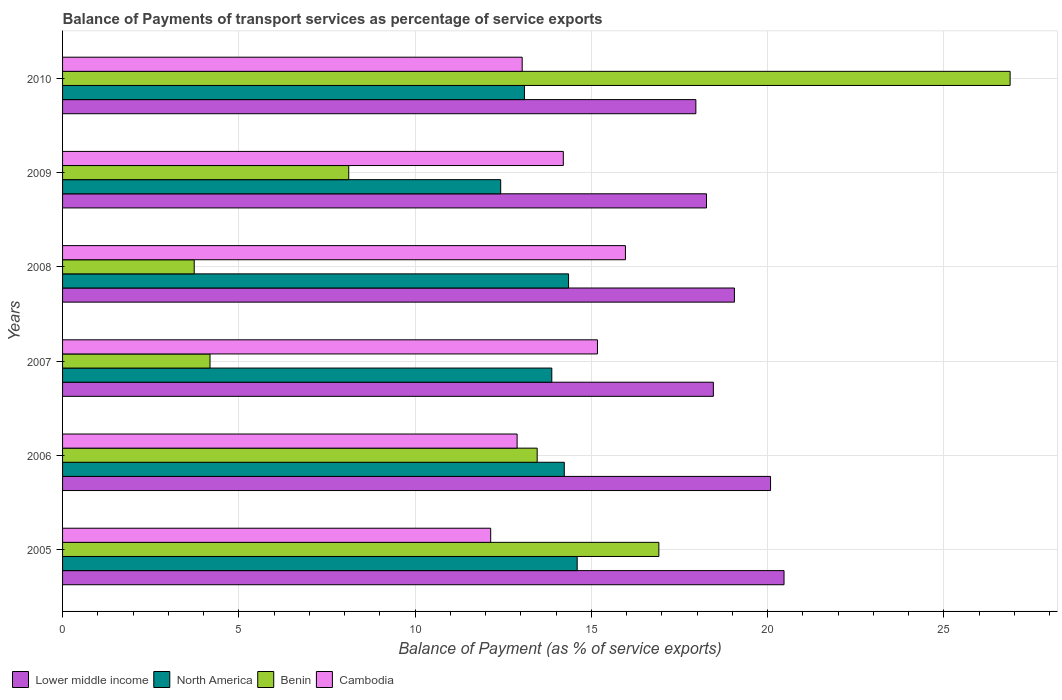How many different coloured bars are there?
Your answer should be very brief. 4. How many groups of bars are there?
Provide a short and direct response. 6. Are the number of bars per tick equal to the number of legend labels?
Offer a very short reply. Yes. Are the number of bars on each tick of the Y-axis equal?
Your answer should be compact. Yes. How many bars are there on the 1st tick from the bottom?
Make the answer very short. 4. What is the label of the 6th group of bars from the top?
Offer a very short reply. 2005. What is the balance of payments of transport services in Cambodia in 2007?
Keep it short and to the point. 15.17. Across all years, what is the maximum balance of payments of transport services in Lower middle income?
Offer a very short reply. 20.47. Across all years, what is the minimum balance of payments of transport services in Lower middle income?
Provide a succinct answer. 17.97. What is the total balance of payments of transport services in Cambodia in the graph?
Ensure brevity in your answer.  83.43. What is the difference between the balance of payments of transport services in North America in 2009 and that in 2010?
Ensure brevity in your answer.  -0.67. What is the difference between the balance of payments of transport services in North America in 2006 and the balance of payments of transport services in Benin in 2009?
Your response must be concise. 6.11. What is the average balance of payments of transport services in North America per year?
Offer a terse response. 13.77. In the year 2009, what is the difference between the balance of payments of transport services in Lower middle income and balance of payments of transport services in North America?
Give a very brief answer. 5.84. What is the ratio of the balance of payments of transport services in Cambodia in 2006 to that in 2007?
Keep it short and to the point. 0.85. Is the balance of payments of transport services in Cambodia in 2005 less than that in 2007?
Give a very brief answer. Yes. What is the difference between the highest and the second highest balance of payments of transport services in North America?
Your answer should be very brief. 0.24. What is the difference between the highest and the lowest balance of payments of transport services in Benin?
Offer a very short reply. 23.15. Is the sum of the balance of payments of transport services in Cambodia in 2005 and 2007 greater than the maximum balance of payments of transport services in North America across all years?
Provide a short and direct response. Yes. Is it the case that in every year, the sum of the balance of payments of transport services in Lower middle income and balance of payments of transport services in North America is greater than the sum of balance of payments of transport services in Cambodia and balance of payments of transport services in Benin?
Provide a succinct answer. Yes. What does the 3rd bar from the top in 2006 represents?
Make the answer very short. North America. What does the 1st bar from the bottom in 2010 represents?
Keep it short and to the point. Lower middle income. Is it the case that in every year, the sum of the balance of payments of transport services in Benin and balance of payments of transport services in North America is greater than the balance of payments of transport services in Lower middle income?
Offer a terse response. No. How many bars are there?
Keep it short and to the point. 24. What is the difference between two consecutive major ticks on the X-axis?
Your response must be concise. 5. Are the values on the major ticks of X-axis written in scientific E-notation?
Make the answer very short. No. Where does the legend appear in the graph?
Make the answer very short. Bottom left. How many legend labels are there?
Your answer should be compact. 4. How are the legend labels stacked?
Provide a succinct answer. Horizontal. What is the title of the graph?
Ensure brevity in your answer.  Balance of Payments of transport services as percentage of service exports. Does "Venezuela" appear as one of the legend labels in the graph?
Your response must be concise. No. What is the label or title of the X-axis?
Ensure brevity in your answer.  Balance of Payment (as % of service exports). What is the Balance of Payment (as % of service exports) in Lower middle income in 2005?
Ensure brevity in your answer.  20.47. What is the Balance of Payment (as % of service exports) in North America in 2005?
Your answer should be very brief. 14.6. What is the Balance of Payment (as % of service exports) in Benin in 2005?
Provide a short and direct response. 16.92. What is the Balance of Payment (as % of service exports) in Cambodia in 2005?
Keep it short and to the point. 12.14. What is the Balance of Payment (as % of service exports) of Lower middle income in 2006?
Keep it short and to the point. 20.08. What is the Balance of Payment (as % of service exports) of North America in 2006?
Provide a succinct answer. 14.23. What is the Balance of Payment (as % of service exports) of Benin in 2006?
Give a very brief answer. 13.46. What is the Balance of Payment (as % of service exports) of Cambodia in 2006?
Keep it short and to the point. 12.89. What is the Balance of Payment (as % of service exports) of Lower middle income in 2007?
Make the answer very short. 18.46. What is the Balance of Payment (as % of service exports) in North America in 2007?
Keep it short and to the point. 13.88. What is the Balance of Payment (as % of service exports) in Benin in 2007?
Keep it short and to the point. 4.18. What is the Balance of Payment (as % of service exports) of Cambodia in 2007?
Provide a succinct answer. 15.17. What is the Balance of Payment (as % of service exports) of Lower middle income in 2008?
Make the answer very short. 19.06. What is the Balance of Payment (as % of service exports) of North America in 2008?
Ensure brevity in your answer.  14.35. What is the Balance of Payment (as % of service exports) of Benin in 2008?
Your response must be concise. 3.73. What is the Balance of Payment (as % of service exports) of Cambodia in 2008?
Offer a terse response. 15.97. What is the Balance of Payment (as % of service exports) in Lower middle income in 2009?
Offer a very short reply. 18.27. What is the Balance of Payment (as % of service exports) in North America in 2009?
Offer a terse response. 12.43. What is the Balance of Payment (as % of service exports) of Benin in 2009?
Keep it short and to the point. 8.12. What is the Balance of Payment (as % of service exports) in Cambodia in 2009?
Ensure brevity in your answer.  14.21. What is the Balance of Payment (as % of service exports) in Lower middle income in 2010?
Keep it short and to the point. 17.97. What is the Balance of Payment (as % of service exports) of North America in 2010?
Make the answer very short. 13.1. What is the Balance of Payment (as % of service exports) in Benin in 2010?
Offer a very short reply. 26.88. What is the Balance of Payment (as % of service exports) in Cambodia in 2010?
Your answer should be compact. 13.04. Across all years, what is the maximum Balance of Payment (as % of service exports) of Lower middle income?
Offer a terse response. 20.47. Across all years, what is the maximum Balance of Payment (as % of service exports) of North America?
Ensure brevity in your answer.  14.6. Across all years, what is the maximum Balance of Payment (as % of service exports) in Benin?
Provide a succinct answer. 26.88. Across all years, what is the maximum Balance of Payment (as % of service exports) of Cambodia?
Your response must be concise. 15.97. Across all years, what is the minimum Balance of Payment (as % of service exports) in Lower middle income?
Make the answer very short. 17.97. Across all years, what is the minimum Balance of Payment (as % of service exports) in North America?
Keep it short and to the point. 12.43. Across all years, what is the minimum Balance of Payment (as % of service exports) of Benin?
Ensure brevity in your answer.  3.73. Across all years, what is the minimum Balance of Payment (as % of service exports) of Cambodia?
Your answer should be very brief. 12.14. What is the total Balance of Payment (as % of service exports) of Lower middle income in the graph?
Your answer should be compact. 114.31. What is the total Balance of Payment (as % of service exports) in North America in the graph?
Offer a very short reply. 82.6. What is the total Balance of Payment (as % of service exports) in Benin in the graph?
Provide a short and direct response. 73.3. What is the total Balance of Payment (as % of service exports) in Cambodia in the graph?
Make the answer very short. 83.43. What is the difference between the Balance of Payment (as % of service exports) of Lower middle income in 2005 and that in 2006?
Keep it short and to the point. 0.38. What is the difference between the Balance of Payment (as % of service exports) in North America in 2005 and that in 2006?
Your answer should be compact. 0.37. What is the difference between the Balance of Payment (as % of service exports) of Benin in 2005 and that in 2006?
Make the answer very short. 3.45. What is the difference between the Balance of Payment (as % of service exports) of Cambodia in 2005 and that in 2006?
Make the answer very short. -0.75. What is the difference between the Balance of Payment (as % of service exports) in Lower middle income in 2005 and that in 2007?
Ensure brevity in your answer.  2. What is the difference between the Balance of Payment (as % of service exports) in North America in 2005 and that in 2007?
Make the answer very short. 0.72. What is the difference between the Balance of Payment (as % of service exports) in Benin in 2005 and that in 2007?
Your answer should be very brief. 12.73. What is the difference between the Balance of Payment (as % of service exports) in Cambodia in 2005 and that in 2007?
Ensure brevity in your answer.  -3.03. What is the difference between the Balance of Payment (as % of service exports) of Lower middle income in 2005 and that in 2008?
Offer a very short reply. 1.41. What is the difference between the Balance of Payment (as % of service exports) of North America in 2005 and that in 2008?
Ensure brevity in your answer.  0.24. What is the difference between the Balance of Payment (as % of service exports) of Benin in 2005 and that in 2008?
Your answer should be compact. 13.18. What is the difference between the Balance of Payment (as % of service exports) of Cambodia in 2005 and that in 2008?
Your response must be concise. -3.82. What is the difference between the Balance of Payment (as % of service exports) of Lower middle income in 2005 and that in 2009?
Offer a very short reply. 2.2. What is the difference between the Balance of Payment (as % of service exports) of North America in 2005 and that in 2009?
Your answer should be very brief. 2.17. What is the difference between the Balance of Payment (as % of service exports) in Benin in 2005 and that in 2009?
Offer a very short reply. 8.8. What is the difference between the Balance of Payment (as % of service exports) in Cambodia in 2005 and that in 2009?
Keep it short and to the point. -2.06. What is the difference between the Balance of Payment (as % of service exports) of Lower middle income in 2005 and that in 2010?
Keep it short and to the point. 2.5. What is the difference between the Balance of Payment (as % of service exports) of North America in 2005 and that in 2010?
Offer a terse response. 1.5. What is the difference between the Balance of Payment (as % of service exports) of Benin in 2005 and that in 2010?
Your answer should be compact. -9.96. What is the difference between the Balance of Payment (as % of service exports) in Cambodia in 2005 and that in 2010?
Give a very brief answer. -0.89. What is the difference between the Balance of Payment (as % of service exports) of Lower middle income in 2006 and that in 2007?
Your answer should be compact. 1.62. What is the difference between the Balance of Payment (as % of service exports) of North America in 2006 and that in 2007?
Give a very brief answer. 0.35. What is the difference between the Balance of Payment (as % of service exports) in Benin in 2006 and that in 2007?
Your response must be concise. 9.28. What is the difference between the Balance of Payment (as % of service exports) in Cambodia in 2006 and that in 2007?
Ensure brevity in your answer.  -2.28. What is the difference between the Balance of Payment (as % of service exports) in Lower middle income in 2006 and that in 2008?
Provide a short and direct response. 1.02. What is the difference between the Balance of Payment (as % of service exports) of North America in 2006 and that in 2008?
Provide a succinct answer. -0.12. What is the difference between the Balance of Payment (as % of service exports) in Benin in 2006 and that in 2008?
Provide a succinct answer. 9.73. What is the difference between the Balance of Payment (as % of service exports) in Cambodia in 2006 and that in 2008?
Your answer should be compact. -3.07. What is the difference between the Balance of Payment (as % of service exports) in Lower middle income in 2006 and that in 2009?
Your answer should be very brief. 1.82. What is the difference between the Balance of Payment (as % of service exports) of North America in 2006 and that in 2009?
Offer a very short reply. 1.8. What is the difference between the Balance of Payment (as % of service exports) in Benin in 2006 and that in 2009?
Provide a succinct answer. 5.35. What is the difference between the Balance of Payment (as % of service exports) in Cambodia in 2006 and that in 2009?
Your answer should be compact. -1.31. What is the difference between the Balance of Payment (as % of service exports) in Lower middle income in 2006 and that in 2010?
Ensure brevity in your answer.  2.12. What is the difference between the Balance of Payment (as % of service exports) in North America in 2006 and that in 2010?
Provide a short and direct response. 1.13. What is the difference between the Balance of Payment (as % of service exports) of Benin in 2006 and that in 2010?
Offer a very short reply. -13.42. What is the difference between the Balance of Payment (as % of service exports) of Cambodia in 2006 and that in 2010?
Make the answer very short. -0.14. What is the difference between the Balance of Payment (as % of service exports) in Lower middle income in 2007 and that in 2008?
Make the answer very short. -0.6. What is the difference between the Balance of Payment (as % of service exports) in North America in 2007 and that in 2008?
Give a very brief answer. -0.48. What is the difference between the Balance of Payment (as % of service exports) of Benin in 2007 and that in 2008?
Your answer should be compact. 0.45. What is the difference between the Balance of Payment (as % of service exports) in Cambodia in 2007 and that in 2008?
Your answer should be compact. -0.79. What is the difference between the Balance of Payment (as % of service exports) of Lower middle income in 2007 and that in 2009?
Ensure brevity in your answer.  0.19. What is the difference between the Balance of Payment (as % of service exports) of North America in 2007 and that in 2009?
Make the answer very short. 1.45. What is the difference between the Balance of Payment (as % of service exports) in Benin in 2007 and that in 2009?
Offer a very short reply. -3.94. What is the difference between the Balance of Payment (as % of service exports) of Cambodia in 2007 and that in 2009?
Your response must be concise. 0.97. What is the difference between the Balance of Payment (as % of service exports) in Lower middle income in 2007 and that in 2010?
Your answer should be compact. 0.5. What is the difference between the Balance of Payment (as % of service exports) in North America in 2007 and that in 2010?
Offer a very short reply. 0.78. What is the difference between the Balance of Payment (as % of service exports) of Benin in 2007 and that in 2010?
Keep it short and to the point. -22.7. What is the difference between the Balance of Payment (as % of service exports) in Cambodia in 2007 and that in 2010?
Ensure brevity in your answer.  2.14. What is the difference between the Balance of Payment (as % of service exports) in Lower middle income in 2008 and that in 2009?
Ensure brevity in your answer.  0.79. What is the difference between the Balance of Payment (as % of service exports) in North America in 2008 and that in 2009?
Offer a terse response. 1.93. What is the difference between the Balance of Payment (as % of service exports) in Benin in 2008 and that in 2009?
Make the answer very short. -4.38. What is the difference between the Balance of Payment (as % of service exports) in Cambodia in 2008 and that in 2009?
Ensure brevity in your answer.  1.76. What is the difference between the Balance of Payment (as % of service exports) of Lower middle income in 2008 and that in 2010?
Give a very brief answer. 1.09. What is the difference between the Balance of Payment (as % of service exports) of North America in 2008 and that in 2010?
Offer a terse response. 1.25. What is the difference between the Balance of Payment (as % of service exports) of Benin in 2008 and that in 2010?
Provide a short and direct response. -23.15. What is the difference between the Balance of Payment (as % of service exports) in Cambodia in 2008 and that in 2010?
Keep it short and to the point. 2.93. What is the difference between the Balance of Payment (as % of service exports) in Lower middle income in 2009 and that in 2010?
Your answer should be very brief. 0.3. What is the difference between the Balance of Payment (as % of service exports) in North America in 2009 and that in 2010?
Give a very brief answer. -0.67. What is the difference between the Balance of Payment (as % of service exports) in Benin in 2009 and that in 2010?
Your answer should be very brief. -18.76. What is the difference between the Balance of Payment (as % of service exports) of Cambodia in 2009 and that in 2010?
Provide a succinct answer. 1.17. What is the difference between the Balance of Payment (as % of service exports) of Lower middle income in 2005 and the Balance of Payment (as % of service exports) of North America in 2006?
Your answer should be compact. 6.23. What is the difference between the Balance of Payment (as % of service exports) in Lower middle income in 2005 and the Balance of Payment (as % of service exports) in Benin in 2006?
Provide a short and direct response. 7. What is the difference between the Balance of Payment (as % of service exports) in Lower middle income in 2005 and the Balance of Payment (as % of service exports) in Cambodia in 2006?
Keep it short and to the point. 7.57. What is the difference between the Balance of Payment (as % of service exports) of North America in 2005 and the Balance of Payment (as % of service exports) of Benin in 2006?
Provide a short and direct response. 1.13. What is the difference between the Balance of Payment (as % of service exports) in North America in 2005 and the Balance of Payment (as % of service exports) in Cambodia in 2006?
Your answer should be compact. 1.7. What is the difference between the Balance of Payment (as % of service exports) of Benin in 2005 and the Balance of Payment (as % of service exports) of Cambodia in 2006?
Provide a succinct answer. 4.02. What is the difference between the Balance of Payment (as % of service exports) in Lower middle income in 2005 and the Balance of Payment (as % of service exports) in North America in 2007?
Provide a succinct answer. 6.59. What is the difference between the Balance of Payment (as % of service exports) of Lower middle income in 2005 and the Balance of Payment (as % of service exports) of Benin in 2007?
Offer a terse response. 16.28. What is the difference between the Balance of Payment (as % of service exports) of Lower middle income in 2005 and the Balance of Payment (as % of service exports) of Cambodia in 2007?
Offer a very short reply. 5.29. What is the difference between the Balance of Payment (as % of service exports) of North America in 2005 and the Balance of Payment (as % of service exports) of Benin in 2007?
Keep it short and to the point. 10.42. What is the difference between the Balance of Payment (as % of service exports) of North America in 2005 and the Balance of Payment (as % of service exports) of Cambodia in 2007?
Give a very brief answer. -0.58. What is the difference between the Balance of Payment (as % of service exports) in Benin in 2005 and the Balance of Payment (as % of service exports) in Cambodia in 2007?
Keep it short and to the point. 1.74. What is the difference between the Balance of Payment (as % of service exports) of Lower middle income in 2005 and the Balance of Payment (as % of service exports) of North America in 2008?
Ensure brevity in your answer.  6.11. What is the difference between the Balance of Payment (as % of service exports) in Lower middle income in 2005 and the Balance of Payment (as % of service exports) in Benin in 2008?
Make the answer very short. 16.73. What is the difference between the Balance of Payment (as % of service exports) in Lower middle income in 2005 and the Balance of Payment (as % of service exports) in Cambodia in 2008?
Your response must be concise. 4.5. What is the difference between the Balance of Payment (as % of service exports) of North America in 2005 and the Balance of Payment (as % of service exports) of Benin in 2008?
Keep it short and to the point. 10.86. What is the difference between the Balance of Payment (as % of service exports) of North America in 2005 and the Balance of Payment (as % of service exports) of Cambodia in 2008?
Provide a short and direct response. -1.37. What is the difference between the Balance of Payment (as % of service exports) in Benin in 2005 and the Balance of Payment (as % of service exports) in Cambodia in 2008?
Your response must be concise. 0.95. What is the difference between the Balance of Payment (as % of service exports) of Lower middle income in 2005 and the Balance of Payment (as % of service exports) of North America in 2009?
Offer a terse response. 8.04. What is the difference between the Balance of Payment (as % of service exports) in Lower middle income in 2005 and the Balance of Payment (as % of service exports) in Benin in 2009?
Give a very brief answer. 12.35. What is the difference between the Balance of Payment (as % of service exports) of Lower middle income in 2005 and the Balance of Payment (as % of service exports) of Cambodia in 2009?
Your response must be concise. 6.26. What is the difference between the Balance of Payment (as % of service exports) of North America in 2005 and the Balance of Payment (as % of service exports) of Benin in 2009?
Offer a very short reply. 6.48. What is the difference between the Balance of Payment (as % of service exports) of North America in 2005 and the Balance of Payment (as % of service exports) of Cambodia in 2009?
Give a very brief answer. 0.39. What is the difference between the Balance of Payment (as % of service exports) of Benin in 2005 and the Balance of Payment (as % of service exports) of Cambodia in 2009?
Your answer should be very brief. 2.71. What is the difference between the Balance of Payment (as % of service exports) of Lower middle income in 2005 and the Balance of Payment (as % of service exports) of North America in 2010?
Your response must be concise. 7.36. What is the difference between the Balance of Payment (as % of service exports) of Lower middle income in 2005 and the Balance of Payment (as % of service exports) of Benin in 2010?
Offer a terse response. -6.41. What is the difference between the Balance of Payment (as % of service exports) of Lower middle income in 2005 and the Balance of Payment (as % of service exports) of Cambodia in 2010?
Your answer should be very brief. 7.43. What is the difference between the Balance of Payment (as % of service exports) of North America in 2005 and the Balance of Payment (as % of service exports) of Benin in 2010?
Provide a succinct answer. -12.28. What is the difference between the Balance of Payment (as % of service exports) of North America in 2005 and the Balance of Payment (as % of service exports) of Cambodia in 2010?
Keep it short and to the point. 1.56. What is the difference between the Balance of Payment (as % of service exports) in Benin in 2005 and the Balance of Payment (as % of service exports) in Cambodia in 2010?
Your response must be concise. 3.88. What is the difference between the Balance of Payment (as % of service exports) of Lower middle income in 2006 and the Balance of Payment (as % of service exports) of North America in 2007?
Your answer should be very brief. 6.21. What is the difference between the Balance of Payment (as % of service exports) in Lower middle income in 2006 and the Balance of Payment (as % of service exports) in Benin in 2007?
Make the answer very short. 15.9. What is the difference between the Balance of Payment (as % of service exports) in Lower middle income in 2006 and the Balance of Payment (as % of service exports) in Cambodia in 2007?
Your answer should be very brief. 4.91. What is the difference between the Balance of Payment (as % of service exports) in North America in 2006 and the Balance of Payment (as % of service exports) in Benin in 2007?
Your response must be concise. 10.05. What is the difference between the Balance of Payment (as % of service exports) in North America in 2006 and the Balance of Payment (as % of service exports) in Cambodia in 2007?
Make the answer very short. -0.94. What is the difference between the Balance of Payment (as % of service exports) of Benin in 2006 and the Balance of Payment (as % of service exports) of Cambodia in 2007?
Your answer should be compact. -1.71. What is the difference between the Balance of Payment (as % of service exports) in Lower middle income in 2006 and the Balance of Payment (as % of service exports) in North America in 2008?
Give a very brief answer. 5.73. What is the difference between the Balance of Payment (as % of service exports) of Lower middle income in 2006 and the Balance of Payment (as % of service exports) of Benin in 2008?
Your answer should be compact. 16.35. What is the difference between the Balance of Payment (as % of service exports) of Lower middle income in 2006 and the Balance of Payment (as % of service exports) of Cambodia in 2008?
Offer a very short reply. 4.12. What is the difference between the Balance of Payment (as % of service exports) of North America in 2006 and the Balance of Payment (as % of service exports) of Benin in 2008?
Give a very brief answer. 10.5. What is the difference between the Balance of Payment (as % of service exports) of North America in 2006 and the Balance of Payment (as % of service exports) of Cambodia in 2008?
Your answer should be compact. -1.73. What is the difference between the Balance of Payment (as % of service exports) in Benin in 2006 and the Balance of Payment (as % of service exports) in Cambodia in 2008?
Your answer should be compact. -2.5. What is the difference between the Balance of Payment (as % of service exports) in Lower middle income in 2006 and the Balance of Payment (as % of service exports) in North America in 2009?
Ensure brevity in your answer.  7.66. What is the difference between the Balance of Payment (as % of service exports) of Lower middle income in 2006 and the Balance of Payment (as % of service exports) of Benin in 2009?
Ensure brevity in your answer.  11.97. What is the difference between the Balance of Payment (as % of service exports) of Lower middle income in 2006 and the Balance of Payment (as % of service exports) of Cambodia in 2009?
Your response must be concise. 5.88. What is the difference between the Balance of Payment (as % of service exports) in North America in 2006 and the Balance of Payment (as % of service exports) in Benin in 2009?
Your answer should be compact. 6.11. What is the difference between the Balance of Payment (as % of service exports) of North America in 2006 and the Balance of Payment (as % of service exports) of Cambodia in 2009?
Give a very brief answer. 0.03. What is the difference between the Balance of Payment (as % of service exports) in Benin in 2006 and the Balance of Payment (as % of service exports) in Cambodia in 2009?
Your answer should be very brief. -0.74. What is the difference between the Balance of Payment (as % of service exports) of Lower middle income in 2006 and the Balance of Payment (as % of service exports) of North America in 2010?
Give a very brief answer. 6.98. What is the difference between the Balance of Payment (as % of service exports) of Lower middle income in 2006 and the Balance of Payment (as % of service exports) of Benin in 2010?
Your answer should be very brief. -6.8. What is the difference between the Balance of Payment (as % of service exports) in Lower middle income in 2006 and the Balance of Payment (as % of service exports) in Cambodia in 2010?
Your response must be concise. 7.05. What is the difference between the Balance of Payment (as % of service exports) of North America in 2006 and the Balance of Payment (as % of service exports) of Benin in 2010?
Offer a terse response. -12.65. What is the difference between the Balance of Payment (as % of service exports) of North America in 2006 and the Balance of Payment (as % of service exports) of Cambodia in 2010?
Provide a succinct answer. 1.19. What is the difference between the Balance of Payment (as % of service exports) of Benin in 2006 and the Balance of Payment (as % of service exports) of Cambodia in 2010?
Keep it short and to the point. 0.43. What is the difference between the Balance of Payment (as % of service exports) of Lower middle income in 2007 and the Balance of Payment (as % of service exports) of North America in 2008?
Offer a terse response. 4.11. What is the difference between the Balance of Payment (as % of service exports) in Lower middle income in 2007 and the Balance of Payment (as % of service exports) in Benin in 2008?
Ensure brevity in your answer.  14.73. What is the difference between the Balance of Payment (as % of service exports) in Lower middle income in 2007 and the Balance of Payment (as % of service exports) in Cambodia in 2008?
Ensure brevity in your answer.  2.49. What is the difference between the Balance of Payment (as % of service exports) of North America in 2007 and the Balance of Payment (as % of service exports) of Benin in 2008?
Make the answer very short. 10.14. What is the difference between the Balance of Payment (as % of service exports) of North America in 2007 and the Balance of Payment (as % of service exports) of Cambodia in 2008?
Offer a very short reply. -2.09. What is the difference between the Balance of Payment (as % of service exports) of Benin in 2007 and the Balance of Payment (as % of service exports) of Cambodia in 2008?
Ensure brevity in your answer.  -11.78. What is the difference between the Balance of Payment (as % of service exports) of Lower middle income in 2007 and the Balance of Payment (as % of service exports) of North America in 2009?
Your answer should be compact. 6.03. What is the difference between the Balance of Payment (as % of service exports) in Lower middle income in 2007 and the Balance of Payment (as % of service exports) in Benin in 2009?
Ensure brevity in your answer.  10.34. What is the difference between the Balance of Payment (as % of service exports) in Lower middle income in 2007 and the Balance of Payment (as % of service exports) in Cambodia in 2009?
Make the answer very short. 4.26. What is the difference between the Balance of Payment (as % of service exports) of North America in 2007 and the Balance of Payment (as % of service exports) of Benin in 2009?
Ensure brevity in your answer.  5.76. What is the difference between the Balance of Payment (as % of service exports) of North America in 2007 and the Balance of Payment (as % of service exports) of Cambodia in 2009?
Ensure brevity in your answer.  -0.33. What is the difference between the Balance of Payment (as % of service exports) in Benin in 2007 and the Balance of Payment (as % of service exports) in Cambodia in 2009?
Your response must be concise. -10.02. What is the difference between the Balance of Payment (as % of service exports) of Lower middle income in 2007 and the Balance of Payment (as % of service exports) of North America in 2010?
Offer a terse response. 5.36. What is the difference between the Balance of Payment (as % of service exports) in Lower middle income in 2007 and the Balance of Payment (as % of service exports) in Benin in 2010?
Keep it short and to the point. -8.42. What is the difference between the Balance of Payment (as % of service exports) in Lower middle income in 2007 and the Balance of Payment (as % of service exports) in Cambodia in 2010?
Ensure brevity in your answer.  5.42. What is the difference between the Balance of Payment (as % of service exports) of North America in 2007 and the Balance of Payment (as % of service exports) of Benin in 2010?
Your answer should be compact. -13. What is the difference between the Balance of Payment (as % of service exports) in North America in 2007 and the Balance of Payment (as % of service exports) in Cambodia in 2010?
Make the answer very short. 0.84. What is the difference between the Balance of Payment (as % of service exports) in Benin in 2007 and the Balance of Payment (as % of service exports) in Cambodia in 2010?
Your answer should be very brief. -8.86. What is the difference between the Balance of Payment (as % of service exports) of Lower middle income in 2008 and the Balance of Payment (as % of service exports) of North America in 2009?
Give a very brief answer. 6.63. What is the difference between the Balance of Payment (as % of service exports) of Lower middle income in 2008 and the Balance of Payment (as % of service exports) of Benin in 2009?
Keep it short and to the point. 10.94. What is the difference between the Balance of Payment (as % of service exports) in Lower middle income in 2008 and the Balance of Payment (as % of service exports) in Cambodia in 2009?
Your response must be concise. 4.85. What is the difference between the Balance of Payment (as % of service exports) in North America in 2008 and the Balance of Payment (as % of service exports) in Benin in 2009?
Your response must be concise. 6.24. What is the difference between the Balance of Payment (as % of service exports) of North America in 2008 and the Balance of Payment (as % of service exports) of Cambodia in 2009?
Your answer should be compact. 0.15. What is the difference between the Balance of Payment (as % of service exports) in Benin in 2008 and the Balance of Payment (as % of service exports) in Cambodia in 2009?
Provide a short and direct response. -10.47. What is the difference between the Balance of Payment (as % of service exports) in Lower middle income in 2008 and the Balance of Payment (as % of service exports) in North America in 2010?
Ensure brevity in your answer.  5.96. What is the difference between the Balance of Payment (as % of service exports) in Lower middle income in 2008 and the Balance of Payment (as % of service exports) in Benin in 2010?
Offer a very short reply. -7.82. What is the difference between the Balance of Payment (as % of service exports) in Lower middle income in 2008 and the Balance of Payment (as % of service exports) in Cambodia in 2010?
Offer a terse response. 6.02. What is the difference between the Balance of Payment (as % of service exports) of North America in 2008 and the Balance of Payment (as % of service exports) of Benin in 2010?
Your response must be concise. -12.53. What is the difference between the Balance of Payment (as % of service exports) in North America in 2008 and the Balance of Payment (as % of service exports) in Cambodia in 2010?
Ensure brevity in your answer.  1.32. What is the difference between the Balance of Payment (as % of service exports) in Benin in 2008 and the Balance of Payment (as % of service exports) in Cambodia in 2010?
Provide a succinct answer. -9.3. What is the difference between the Balance of Payment (as % of service exports) in Lower middle income in 2009 and the Balance of Payment (as % of service exports) in North America in 2010?
Provide a succinct answer. 5.16. What is the difference between the Balance of Payment (as % of service exports) in Lower middle income in 2009 and the Balance of Payment (as % of service exports) in Benin in 2010?
Provide a succinct answer. -8.61. What is the difference between the Balance of Payment (as % of service exports) of Lower middle income in 2009 and the Balance of Payment (as % of service exports) of Cambodia in 2010?
Make the answer very short. 5.23. What is the difference between the Balance of Payment (as % of service exports) of North America in 2009 and the Balance of Payment (as % of service exports) of Benin in 2010?
Your response must be concise. -14.45. What is the difference between the Balance of Payment (as % of service exports) of North America in 2009 and the Balance of Payment (as % of service exports) of Cambodia in 2010?
Provide a short and direct response. -0.61. What is the difference between the Balance of Payment (as % of service exports) in Benin in 2009 and the Balance of Payment (as % of service exports) in Cambodia in 2010?
Provide a short and direct response. -4.92. What is the average Balance of Payment (as % of service exports) of Lower middle income per year?
Give a very brief answer. 19.05. What is the average Balance of Payment (as % of service exports) of North America per year?
Keep it short and to the point. 13.77. What is the average Balance of Payment (as % of service exports) in Benin per year?
Your answer should be very brief. 12.22. What is the average Balance of Payment (as % of service exports) of Cambodia per year?
Offer a very short reply. 13.9. In the year 2005, what is the difference between the Balance of Payment (as % of service exports) of Lower middle income and Balance of Payment (as % of service exports) of North America?
Make the answer very short. 5.87. In the year 2005, what is the difference between the Balance of Payment (as % of service exports) in Lower middle income and Balance of Payment (as % of service exports) in Benin?
Provide a succinct answer. 3.55. In the year 2005, what is the difference between the Balance of Payment (as % of service exports) in Lower middle income and Balance of Payment (as % of service exports) in Cambodia?
Ensure brevity in your answer.  8.32. In the year 2005, what is the difference between the Balance of Payment (as % of service exports) of North America and Balance of Payment (as % of service exports) of Benin?
Keep it short and to the point. -2.32. In the year 2005, what is the difference between the Balance of Payment (as % of service exports) of North America and Balance of Payment (as % of service exports) of Cambodia?
Your answer should be compact. 2.45. In the year 2005, what is the difference between the Balance of Payment (as % of service exports) in Benin and Balance of Payment (as % of service exports) in Cambodia?
Provide a succinct answer. 4.77. In the year 2006, what is the difference between the Balance of Payment (as % of service exports) in Lower middle income and Balance of Payment (as % of service exports) in North America?
Make the answer very short. 5.85. In the year 2006, what is the difference between the Balance of Payment (as % of service exports) of Lower middle income and Balance of Payment (as % of service exports) of Benin?
Provide a short and direct response. 6.62. In the year 2006, what is the difference between the Balance of Payment (as % of service exports) in Lower middle income and Balance of Payment (as % of service exports) in Cambodia?
Ensure brevity in your answer.  7.19. In the year 2006, what is the difference between the Balance of Payment (as % of service exports) of North America and Balance of Payment (as % of service exports) of Benin?
Offer a very short reply. 0.77. In the year 2006, what is the difference between the Balance of Payment (as % of service exports) of North America and Balance of Payment (as % of service exports) of Cambodia?
Your response must be concise. 1.34. In the year 2006, what is the difference between the Balance of Payment (as % of service exports) of Benin and Balance of Payment (as % of service exports) of Cambodia?
Provide a succinct answer. 0.57. In the year 2007, what is the difference between the Balance of Payment (as % of service exports) in Lower middle income and Balance of Payment (as % of service exports) in North America?
Your answer should be compact. 4.58. In the year 2007, what is the difference between the Balance of Payment (as % of service exports) of Lower middle income and Balance of Payment (as % of service exports) of Benin?
Provide a succinct answer. 14.28. In the year 2007, what is the difference between the Balance of Payment (as % of service exports) in Lower middle income and Balance of Payment (as % of service exports) in Cambodia?
Keep it short and to the point. 3.29. In the year 2007, what is the difference between the Balance of Payment (as % of service exports) in North America and Balance of Payment (as % of service exports) in Benin?
Ensure brevity in your answer.  9.7. In the year 2007, what is the difference between the Balance of Payment (as % of service exports) of North America and Balance of Payment (as % of service exports) of Cambodia?
Offer a terse response. -1.3. In the year 2007, what is the difference between the Balance of Payment (as % of service exports) of Benin and Balance of Payment (as % of service exports) of Cambodia?
Your answer should be compact. -10.99. In the year 2008, what is the difference between the Balance of Payment (as % of service exports) in Lower middle income and Balance of Payment (as % of service exports) in North America?
Provide a succinct answer. 4.71. In the year 2008, what is the difference between the Balance of Payment (as % of service exports) of Lower middle income and Balance of Payment (as % of service exports) of Benin?
Ensure brevity in your answer.  15.32. In the year 2008, what is the difference between the Balance of Payment (as % of service exports) of Lower middle income and Balance of Payment (as % of service exports) of Cambodia?
Offer a terse response. 3.09. In the year 2008, what is the difference between the Balance of Payment (as % of service exports) of North America and Balance of Payment (as % of service exports) of Benin?
Your answer should be compact. 10.62. In the year 2008, what is the difference between the Balance of Payment (as % of service exports) of North America and Balance of Payment (as % of service exports) of Cambodia?
Provide a short and direct response. -1.61. In the year 2008, what is the difference between the Balance of Payment (as % of service exports) in Benin and Balance of Payment (as % of service exports) in Cambodia?
Offer a very short reply. -12.23. In the year 2009, what is the difference between the Balance of Payment (as % of service exports) of Lower middle income and Balance of Payment (as % of service exports) of North America?
Give a very brief answer. 5.84. In the year 2009, what is the difference between the Balance of Payment (as % of service exports) in Lower middle income and Balance of Payment (as % of service exports) in Benin?
Give a very brief answer. 10.15. In the year 2009, what is the difference between the Balance of Payment (as % of service exports) in Lower middle income and Balance of Payment (as % of service exports) in Cambodia?
Your response must be concise. 4.06. In the year 2009, what is the difference between the Balance of Payment (as % of service exports) in North America and Balance of Payment (as % of service exports) in Benin?
Offer a terse response. 4.31. In the year 2009, what is the difference between the Balance of Payment (as % of service exports) of North America and Balance of Payment (as % of service exports) of Cambodia?
Your answer should be compact. -1.78. In the year 2009, what is the difference between the Balance of Payment (as % of service exports) in Benin and Balance of Payment (as % of service exports) in Cambodia?
Provide a succinct answer. -6.09. In the year 2010, what is the difference between the Balance of Payment (as % of service exports) of Lower middle income and Balance of Payment (as % of service exports) of North America?
Provide a succinct answer. 4.86. In the year 2010, what is the difference between the Balance of Payment (as % of service exports) in Lower middle income and Balance of Payment (as % of service exports) in Benin?
Keep it short and to the point. -8.91. In the year 2010, what is the difference between the Balance of Payment (as % of service exports) of Lower middle income and Balance of Payment (as % of service exports) of Cambodia?
Your answer should be very brief. 4.93. In the year 2010, what is the difference between the Balance of Payment (as % of service exports) in North America and Balance of Payment (as % of service exports) in Benin?
Ensure brevity in your answer.  -13.78. In the year 2010, what is the difference between the Balance of Payment (as % of service exports) in North America and Balance of Payment (as % of service exports) in Cambodia?
Provide a succinct answer. 0.06. In the year 2010, what is the difference between the Balance of Payment (as % of service exports) of Benin and Balance of Payment (as % of service exports) of Cambodia?
Your response must be concise. 13.84. What is the ratio of the Balance of Payment (as % of service exports) of Lower middle income in 2005 to that in 2006?
Your answer should be very brief. 1.02. What is the ratio of the Balance of Payment (as % of service exports) of North America in 2005 to that in 2006?
Make the answer very short. 1.03. What is the ratio of the Balance of Payment (as % of service exports) of Benin in 2005 to that in 2006?
Your answer should be very brief. 1.26. What is the ratio of the Balance of Payment (as % of service exports) in Cambodia in 2005 to that in 2006?
Ensure brevity in your answer.  0.94. What is the ratio of the Balance of Payment (as % of service exports) in Lower middle income in 2005 to that in 2007?
Make the answer very short. 1.11. What is the ratio of the Balance of Payment (as % of service exports) in North America in 2005 to that in 2007?
Provide a short and direct response. 1.05. What is the ratio of the Balance of Payment (as % of service exports) in Benin in 2005 to that in 2007?
Offer a very short reply. 4.04. What is the ratio of the Balance of Payment (as % of service exports) of Cambodia in 2005 to that in 2007?
Ensure brevity in your answer.  0.8. What is the ratio of the Balance of Payment (as % of service exports) of Lower middle income in 2005 to that in 2008?
Provide a succinct answer. 1.07. What is the ratio of the Balance of Payment (as % of service exports) in North America in 2005 to that in 2008?
Offer a very short reply. 1.02. What is the ratio of the Balance of Payment (as % of service exports) of Benin in 2005 to that in 2008?
Your response must be concise. 4.53. What is the ratio of the Balance of Payment (as % of service exports) in Cambodia in 2005 to that in 2008?
Offer a very short reply. 0.76. What is the ratio of the Balance of Payment (as % of service exports) of Lower middle income in 2005 to that in 2009?
Make the answer very short. 1.12. What is the ratio of the Balance of Payment (as % of service exports) in North America in 2005 to that in 2009?
Provide a short and direct response. 1.17. What is the ratio of the Balance of Payment (as % of service exports) of Benin in 2005 to that in 2009?
Ensure brevity in your answer.  2.08. What is the ratio of the Balance of Payment (as % of service exports) of Cambodia in 2005 to that in 2009?
Provide a succinct answer. 0.85. What is the ratio of the Balance of Payment (as % of service exports) in Lower middle income in 2005 to that in 2010?
Offer a terse response. 1.14. What is the ratio of the Balance of Payment (as % of service exports) in North America in 2005 to that in 2010?
Provide a short and direct response. 1.11. What is the ratio of the Balance of Payment (as % of service exports) in Benin in 2005 to that in 2010?
Provide a succinct answer. 0.63. What is the ratio of the Balance of Payment (as % of service exports) of Cambodia in 2005 to that in 2010?
Give a very brief answer. 0.93. What is the ratio of the Balance of Payment (as % of service exports) of Lower middle income in 2006 to that in 2007?
Offer a very short reply. 1.09. What is the ratio of the Balance of Payment (as % of service exports) in North America in 2006 to that in 2007?
Provide a short and direct response. 1.03. What is the ratio of the Balance of Payment (as % of service exports) in Benin in 2006 to that in 2007?
Ensure brevity in your answer.  3.22. What is the ratio of the Balance of Payment (as % of service exports) in Cambodia in 2006 to that in 2007?
Ensure brevity in your answer.  0.85. What is the ratio of the Balance of Payment (as % of service exports) in Lower middle income in 2006 to that in 2008?
Keep it short and to the point. 1.05. What is the ratio of the Balance of Payment (as % of service exports) in North America in 2006 to that in 2008?
Offer a very short reply. 0.99. What is the ratio of the Balance of Payment (as % of service exports) of Benin in 2006 to that in 2008?
Provide a short and direct response. 3.6. What is the ratio of the Balance of Payment (as % of service exports) of Cambodia in 2006 to that in 2008?
Give a very brief answer. 0.81. What is the ratio of the Balance of Payment (as % of service exports) in Lower middle income in 2006 to that in 2009?
Offer a very short reply. 1.1. What is the ratio of the Balance of Payment (as % of service exports) of North America in 2006 to that in 2009?
Your answer should be very brief. 1.15. What is the ratio of the Balance of Payment (as % of service exports) in Benin in 2006 to that in 2009?
Your response must be concise. 1.66. What is the ratio of the Balance of Payment (as % of service exports) of Cambodia in 2006 to that in 2009?
Your answer should be compact. 0.91. What is the ratio of the Balance of Payment (as % of service exports) of Lower middle income in 2006 to that in 2010?
Give a very brief answer. 1.12. What is the ratio of the Balance of Payment (as % of service exports) in North America in 2006 to that in 2010?
Provide a succinct answer. 1.09. What is the ratio of the Balance of Payment (as % of service exports) of Benin in 2006 to that in 2010?
Provide a short and direct response. 0.5. What is the ratio of the Balance of Payment (as % of service exports) of Cambodia in 2006 to that in 2010?
Offer a very short reply. 0.99. What is the ratio of the Balance of Payment (as % of service exports) in Lower middle income in 2007 to that in 2008?
Ensure brevity in your answer.  0.97. What is the ratio of the Balance of Payment (as % of service exports) in North America in 2007 to that in 2008?
Give a very brief answer. 0.97. What is the ratio of the Balance of Payment (as % of service exports) of Benin in 2007 to that in 2008?
Your answer should be very brief. 1.12. What is the ratio of the Balance of Payment (as % of service exports) of Cambodia in 2007 to that in 2008?
Offer a terse response. 0.95. What is the ratio of the Balance of Payment (as % of service exports) of Lower middle income in 2007 to that in 2009?
Make the answer very short. 1.01. What is the ratio of the Balance of Payment (as % of service exports) in North America in 2007 to that in 2009?
Your answer should be compact. 1.12. What is the ratio of the Balance of Payment (as % of service exports) in Benin in 2007 to that in 2009?
Your response must be concise. 0.52. What is the ratio of the Balance of Payment (as % of service exports) of Cambodia in 2007 to that in 2009?
Offer a terse response. 1.07. What is the ratio of the Balance of Payment (as % of service exports) in Lower middle income in 2007 to that in 2010?
Make the answer very short. 1.03. What is the ratio of the Balance of Payment (as % of service exports) in North America in 2007 to that in 2010?
Offer a very short reply. 1.06. What is the ratio of the Balance of Payment (as % of service exports) of Benin in 2007 to that in 2010?
Ensure brevity in your answer.  0.16. What is the ratio of the Balance of Payment (as % of service exports) of Cambodia in 2007 to that in 2010?
Your response must be concise. 1.16. What is the ratio of the Balance of Payment (as % of service exports) of Lower middle income in 2008 to that in 2009?
Provide a succinct answer. 1.04. What is the ratio of the Balance of Payment (as % of service exports) in North America in 2008 to that in 2009?
Your answer should be very brief. 1.15. What is the ratio of the Balance of Payment (as % of service exports) of Benin in 2008 to that in 2009?
Offer a very short reply. 0.46. What is the ratio of the Balance of Payment (as % of service exports) of Cambodia in 2008 to that in 2009?
Your response must be concise. 1.12. What is the ratio of the Balance of Payment (as % of service exports) of Lower middle income in 2008 to that in 2010?
Offer a very short reply. 1.06. What is the ratio of the Balance of Payment (as % of service exports) in North America in 2008 to that in 2010?
Provide a succinct answer. 1.1. What is the ratio of the Balance of Payment (as % of service exports) in Benin in 2008 to that in 2010?
Make the answer very short. 0.14. What is the ratio of the Balance of Payment (as % of service exports) in Cambodia in 2008 to that in 2010?
Make the answer very short. 1.22. What is the ratio of the Balance of Payment (as % of service exports) in Lower middle income in 2009 to that in 2010?
Make the answer very short. 1.02. What is the ratio of the Balance of Payment (as % of service exports) of North America in 2009 to that in 2010?
Offer a terse response. 0.95. What is the ratio of the Balance of Payment (as % of service exports) of Benin in 2009 to that in 2010?
Your answer should be very brief. 0.3. What is the ratio of the Balance of Payment (as % of service exports) of Cambodia in 2009 to that in 2010?
Provide a short and direct response. 1.09. What is the difference between the highest and the second highest Balance of Payment (as % of service exports) in Lower middle income?
Your answer should be very brief. 0.38. What is the difference between the highest and the second highest Balance of Payment (as % of service exports) in North America?
Offer a terse response. 0.24. What is the difference between the highest and the second highest Balance of Payment (as % of service exports) in Benin?
Your response must be concise. 9.96. What is the difference between the highest and the second highest Balance of Payment (as % of service exports) in Cambodia?
Make the answer very short. 0.79. What is the difference between the highest and the lowest Balance of Payment (as % of service exports) in Lower middle income?
Your answer should be compact. 2.5. What is the difference between the highest and the lowest Balance of Payment (as % of service exports) in North America?
Your answer should be very brief. 2.17. What is the difference between the highest and the lowest Balance of Payment (as % of service exports) of Benin?
Your answer should be very brief. 23.15. What is the difference between the highest and the lowest Balance of Payment (as % of service exports) of Cambodia?
Your response must be concise. 3.82. 